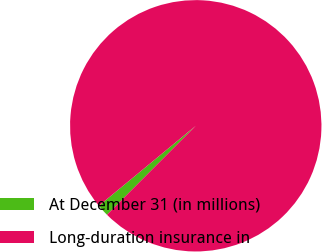Convert chart to OTSL. <chart><loc_0><loc_0><loc_500><loc_500><pie_chart><fcel>At December 31 (in millions)<fcel>Long-duration insurance in<nl><fcel>1.53%<fcel>98.47%<nl></chart> 